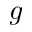<formula> <loc_0><loc_0><loc_500><loc_500>g</formula> 